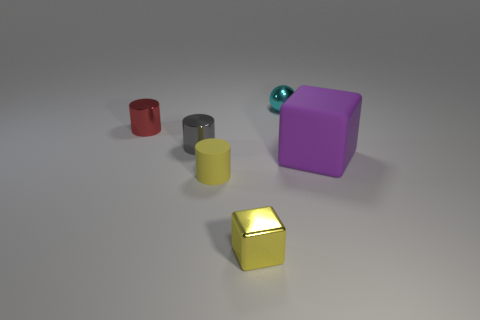Add 4 cyan things. How many objects exist? 10 Subtract all spheres. How many objects are left? 5 Add 6 metallic cylinders. How many metallic cylinders are left? 8 Add 4 red things. How many red things exist? 5 Subtract 0 brown cylinders. How many objects are left? 6 Subtract all tiny red metal things. Subtract all yellow shiny things. How many objects are left? 4 